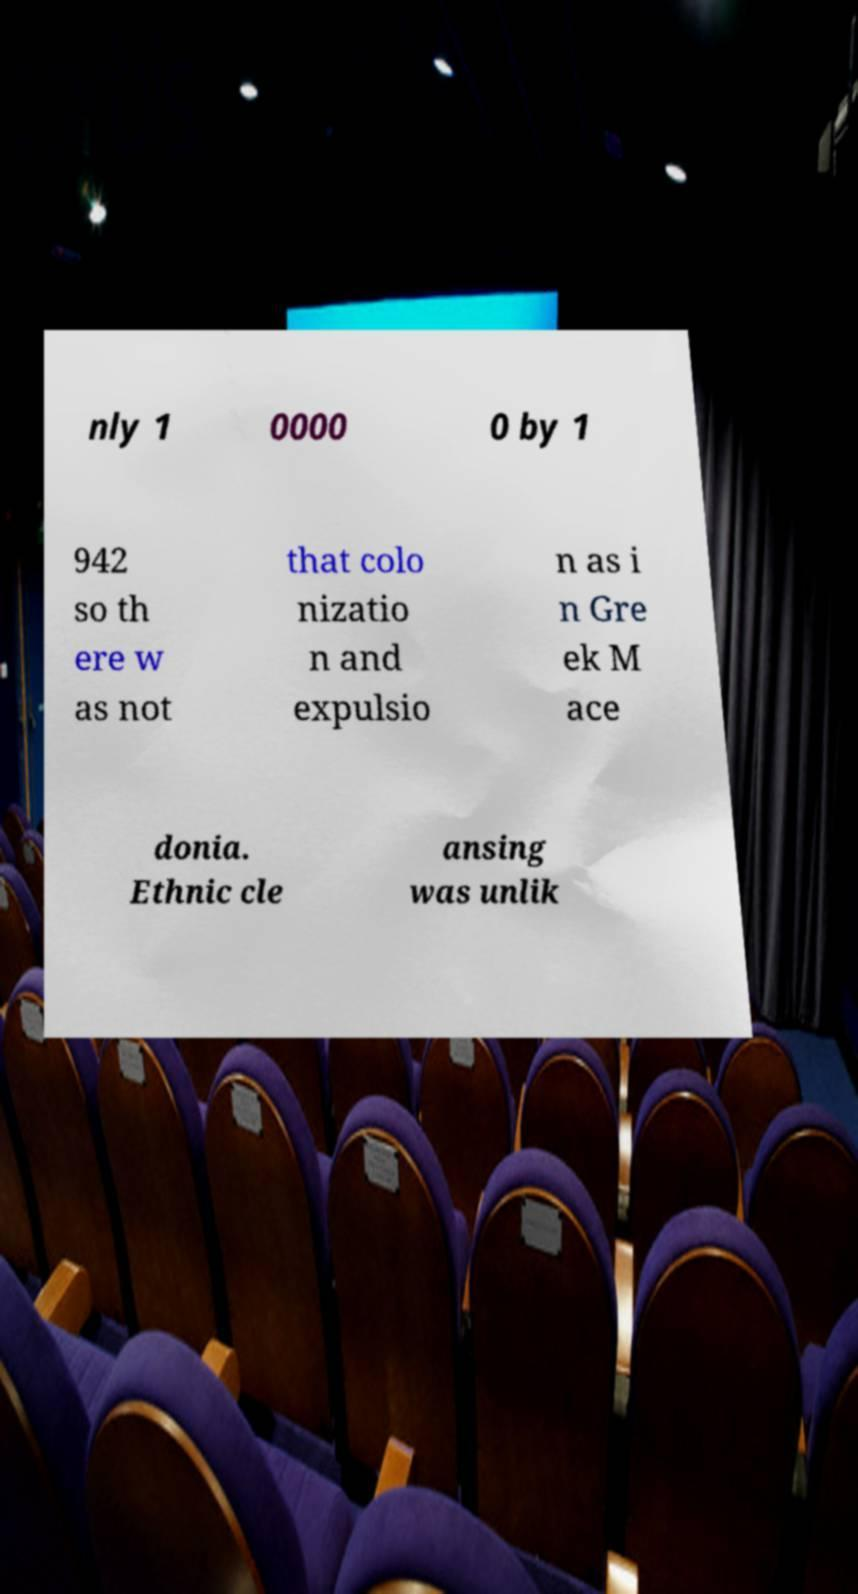Can you read and provide the text displayed in the image?This photo seems to have some interesting text. Can you extract and type it out for me? nly 1 0000 0 by 1 942 so th ere w as not that colo nizatio n and expulsio n as i n Gre ek M ace donia. Ethnic cle ansing was unlik 